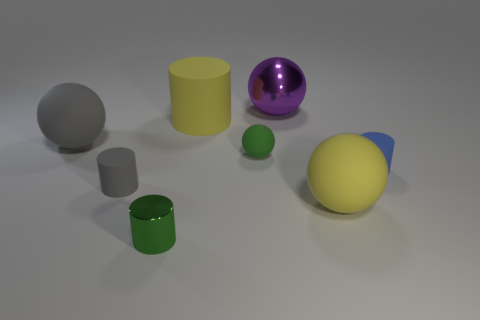Could you speculate on the materials these objects might represent in a real-world setting? In a real-world setting, the glossy finish on the green and purple objects suggests they could be made of polished metal or plastic, exhibiting reflective properties. The matte gray objects resemble stone or concrete due to their non-reflective surface. The yellow and blue capsule could represent a coated pill or a part of a toy, given its vibrant and less realistic colors. 